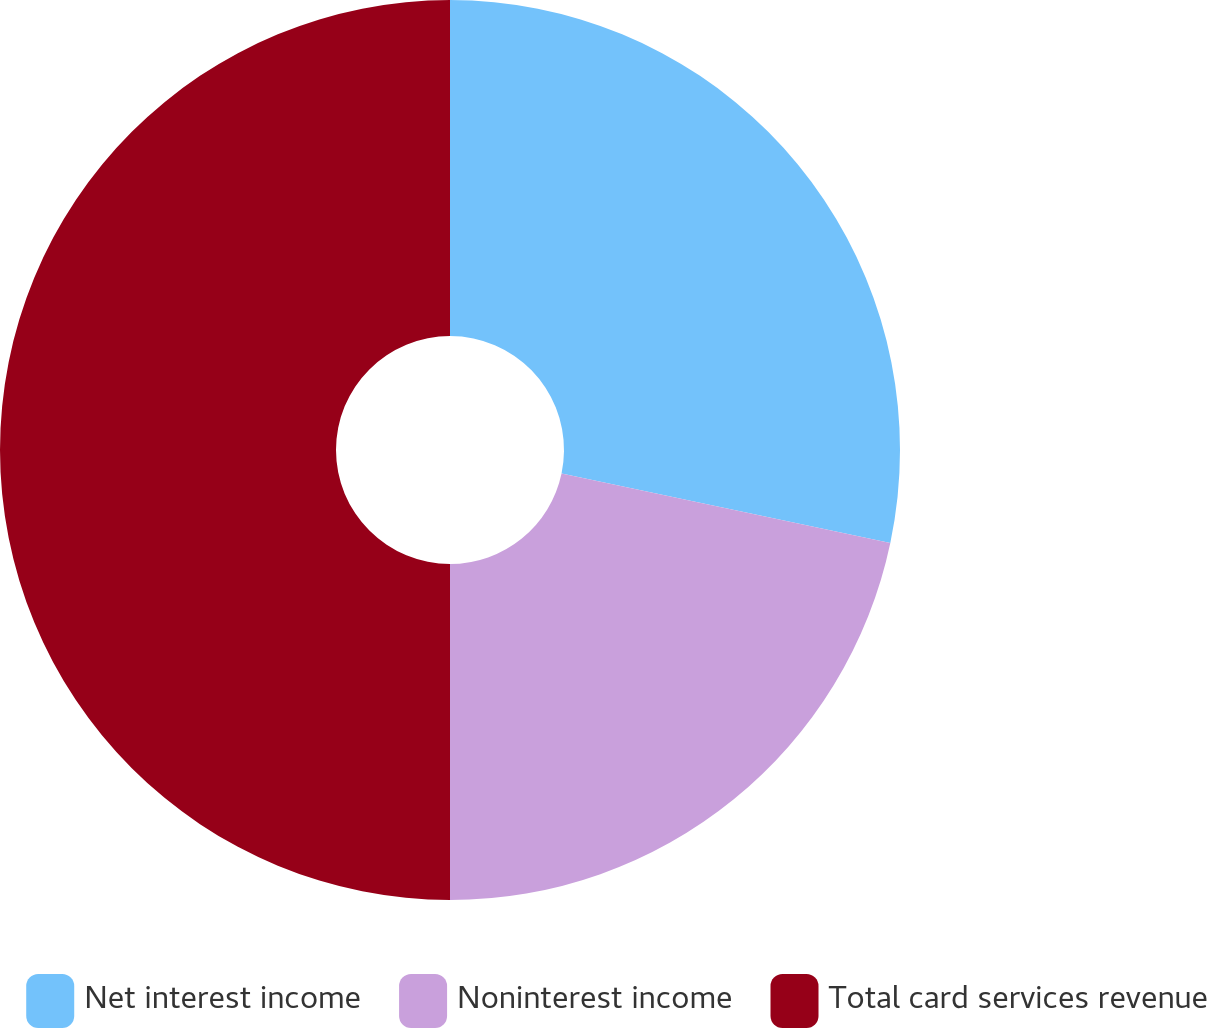Convert chart. <chart><loc_0><loc_0><loc_500><loc_500><pie_chart><fcel>Net interest income<fcel>Noninterest income<fcel>Total card services revenue<nl><fcel>28.31%<fcel>21.69%<fcel>50.0%<nl></chart> 